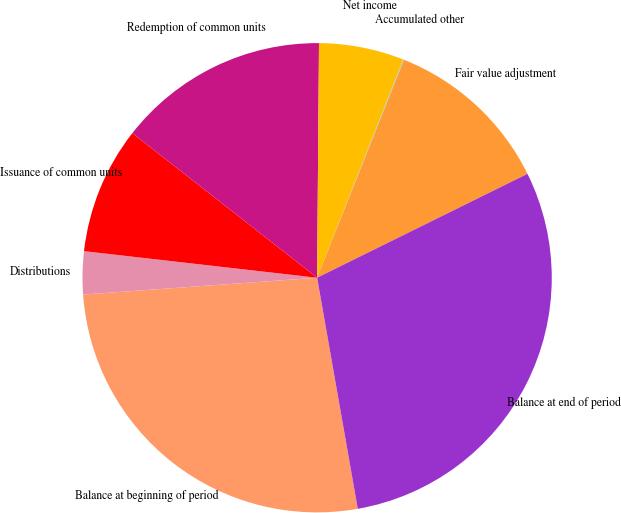Convert chart to OTSL. <chart><loc_0><loc_0><loc_500><loc_500><pie_chart><fcel>Balance at beginning of period<fcel>Distributions<fcel>Issuance of common units<fcel>Redemption of common units<fcel>Net income<fcel>Accumulated other<fcel>Fair value adjustment<fcel>Balance at end of period<nl><fcel>26.63%<fcel>2.95%<fcel>8.76%<fcel>14.56%<fcel>5.86%<fcel>0.05%<fcel>11.66%<fcel>29.53%<nl></chart> 